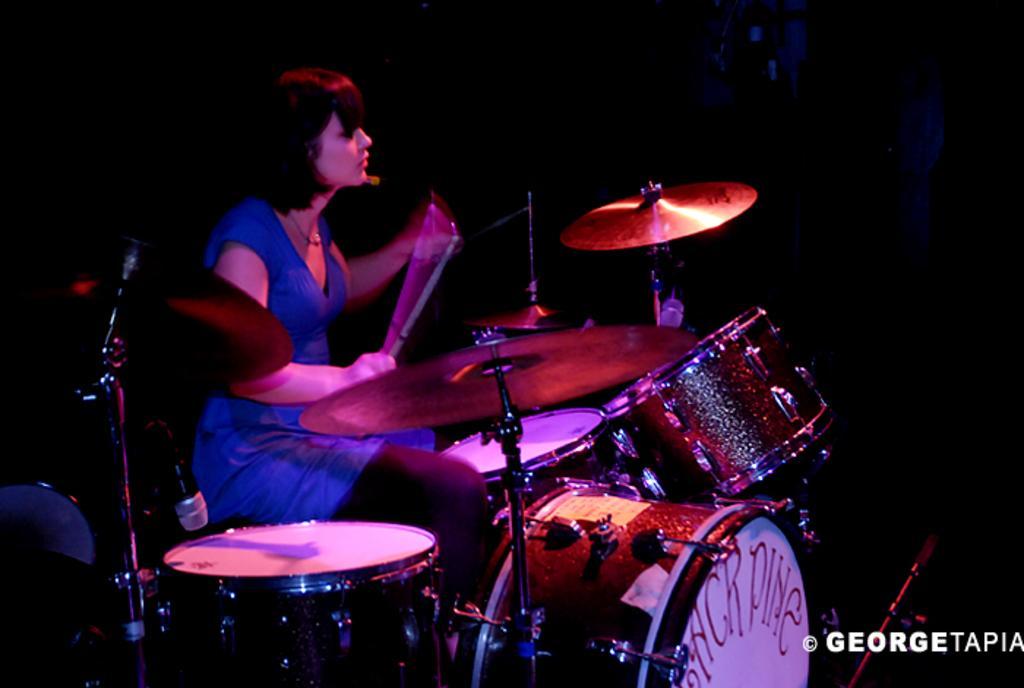In one or two sentences, can you explain what this image depicts? In this picture I can see a woman sitting, there are mikes with the mikes stands, there are drums, there are cymbals with the cymbals stands, there is dark background and there is a watermark on the image. 